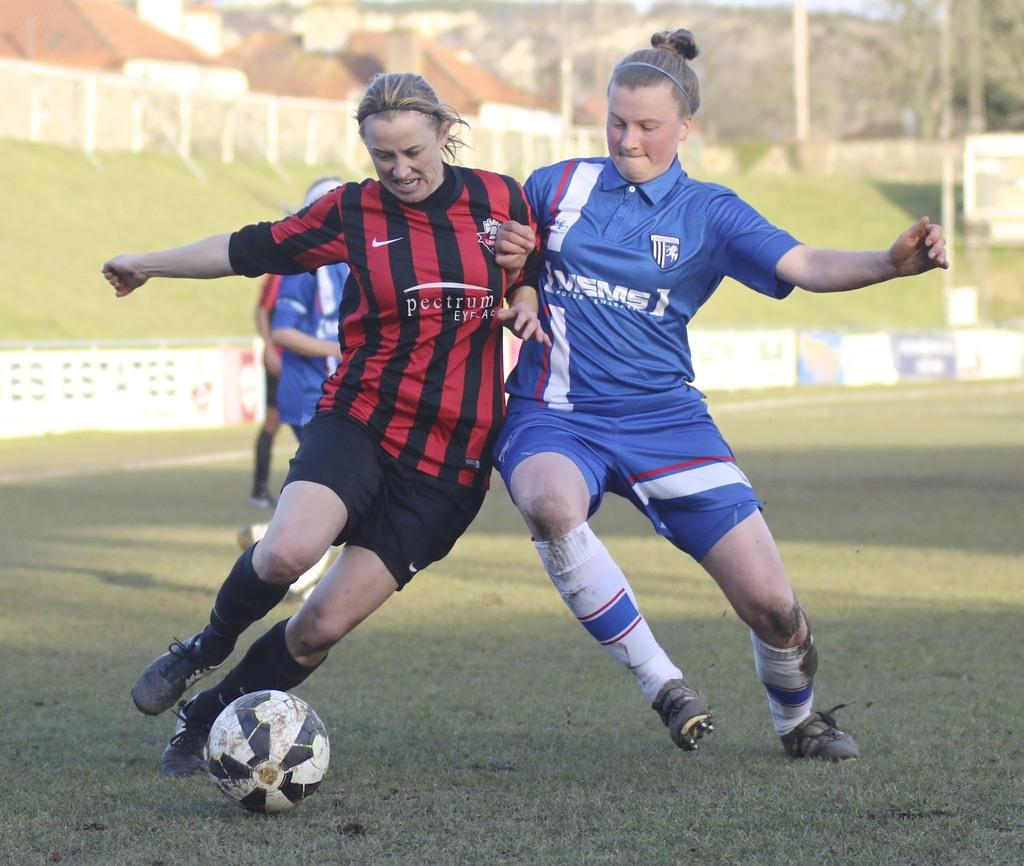How many women are in the image? There are two women in the image. What are the women doing in the image? The women are on the ground and trying to hit a football. Can you describe the background of the image? In the background of the image, there are two persons, poles, grass, hoardings, houses, trees, and the sky. Are there any ships visible in the image? No, there are no ships present in the image. Can you describe the type of bears that can be seen in the image? There are no bears present in the image. 